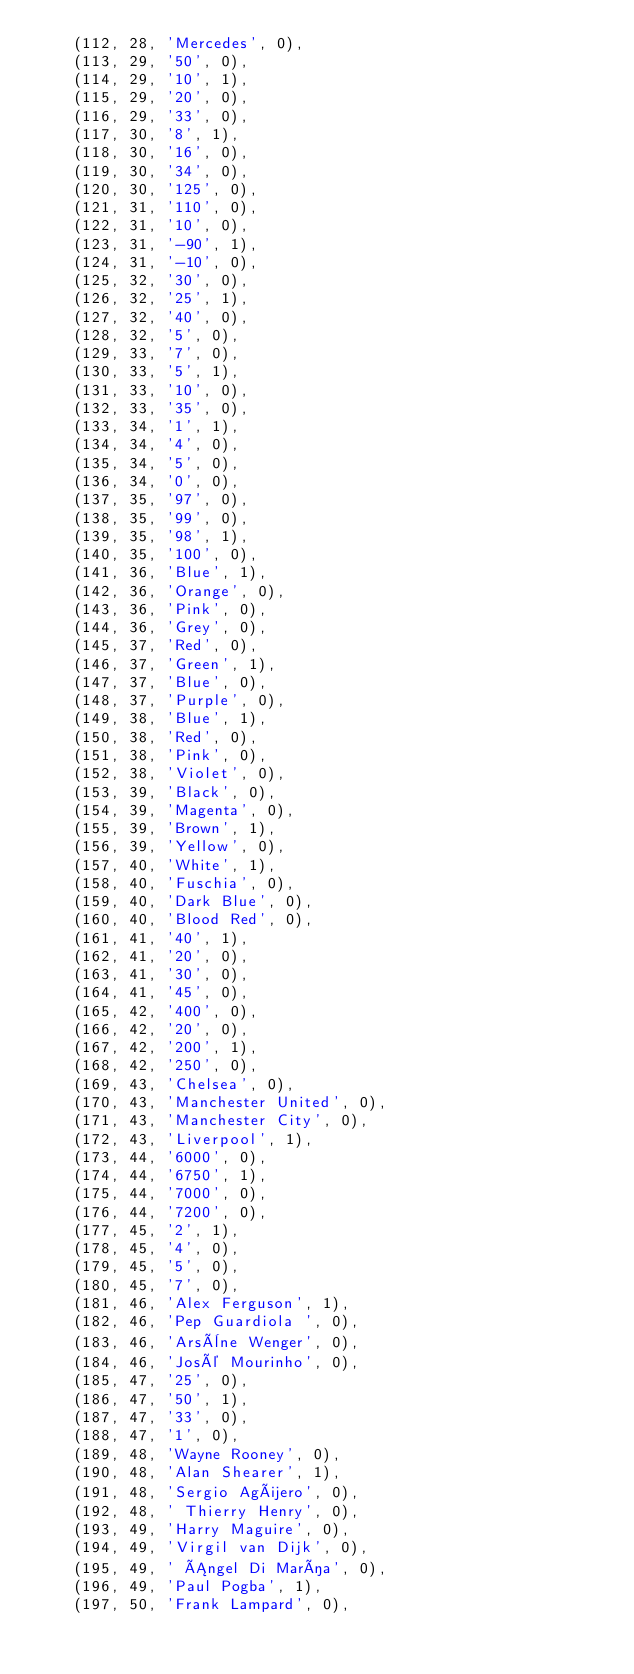Convert code to text. <code><loc_0><loc_0><loc_500><loc_500><_SQL_>	(112, 28, 'Mercedes', 0),
	(113, 29, '50', 0),
	(114, 29, '10', 1),
	(115, 29, '20', 0),
	(116, 29, '33', 0),
	(117, 30, '8', 1),
	(118, 30, '16', 0),
	(119, 30, '34', 0),
	(120, 30, '125', 0),
	(121, 31, '110', 0),
	(122, 31, '10', 0),
	(123, 31, '-90', 1),
	(124, 31, '-10', 0),
	(125, 32, '30', 0),
	(126, 32, '25', 1),
	(127, 32, '40', 0),
	(128, 32, '5', 0),
	(129, 33, '7', 0),
	(130, 33, '5', 1),
	(131, 33, '10', 0),
	(132, 33, '35', 0),
	(133, 34, '1', 1),
	(134, 34, '4', 0),
	(135, 34, '5', 0),
	(136, 34, '0', 0),
	(137, 35, '97', 0),
	(138, 35, '99', 0),
	(139, 35, '98', 1),
	(140, 35, '100', 0),
	(141, 36, 'Blue', 1),
	(142, 36, 'Orange', 0),
	(143, 36, 'Pink', 0),
	(144, 36, 'Grey', 0),
	(145, 37, 'Red', 0),
	(146, 37, 'Green', 1),
	(147, 37, 'Blue', 0),
	(148, 37, 'Purple', 0),
	(149, 38, 'Blue', 1),
	(150, 38, 'Red', 0),
	(151, 38, 'Pink', 0),
	(152, 38, 'Violet', 0),
	(153, 39, 'Black', 0),
	(154, 39, 'Magenta', 0),
	(155, 39, 'Brown', 1),
	(156, 39, 'Yellow', 0),
	(157, 40, 'White', 1),
	(158, 40, 'Fuschia', 0),
	(159, 40, 'Dark Blue', 0),
	(160, 40, 'Blood Red', 0),
	(161, 41, '40', 1),
	(162, 41, '20', 0),
	(163, 41, '30', 0),
	(164, 41, '45', 0),
	(165, 42, '400', 0),
	(166, 42, '20', 0),
	(167, 42, '200', 1),
	(168, 42, '250', 0),
	(169, 43, 'Chelsea', 0),
	(170, 43, 'Manchester United', 0),
	(171, 43, 'Manchester City', 0),
	(172, 43, 'Liverpool', 1),
	(173, 44, '6000', 0),
	(174, 44, '6750', 1),
	(175, 44, '7000', 0),
	(176, 44, '7200', 0),
	(177, 45, '2', 1),
	(178, 45, '4', 0),
	(179, 45, '5', 0),
	(180, 45, '7', 0),
	(181, 46, 'Alex Ferguson', 1),
	(182, 46, 'Pep Guardiola ', 0),
	(183, 46, 'Arsène Wenger', 0),
	(184, 46, 'José Mourinho', 0),
	(185, 47, '25', 0),
	(186, 47, '50', 1),
	(187, 47, '33', 0),
	(188, 47, '1', 0),
	(189, 48, 'Wayne Rooney', 0),
	(190, 48, 'Alan Shearer', 1),
	(191, 48, 'Sergio Agüero', 0),
	(192, 48, ' Thierry Henry', 0),
	(193, 49, 'Harry Maguire', 0),
	(194, 49, 'Virgil van Dijk', 0),
	(195, 49, ' Ángel Di María', 0),
	(196, 49, 'Paul Pogba', 1),
	(197, 50, 'Frank Lampard', 0),</code> 